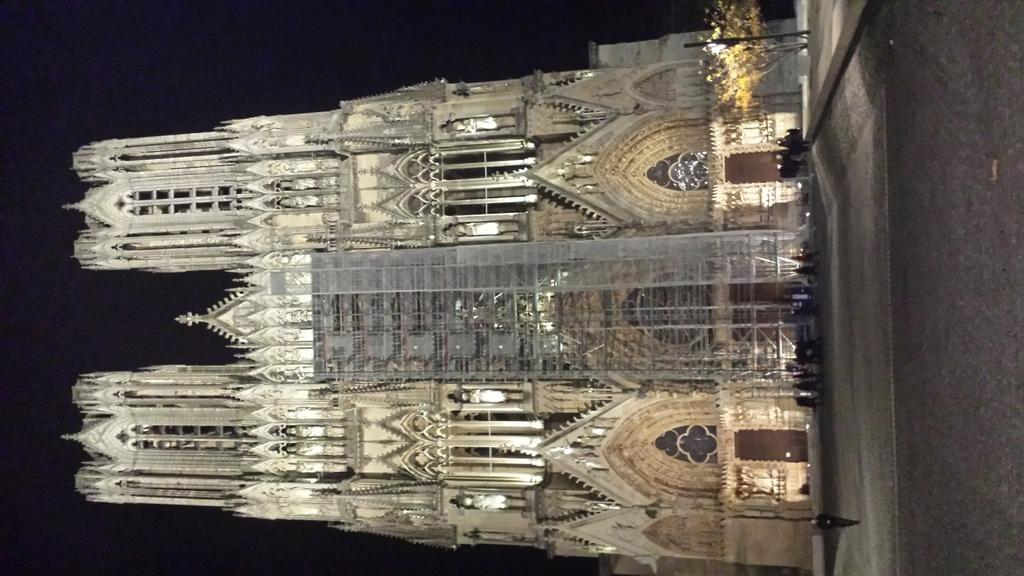What structure is present in the image? There is a building in the image. Can you describe the people in the image? There are persons in the image. What type of vegetation is visible in the image? There are trees in the image. What is the pole in the image used for? The pole in the image is likely used for supporting something, such as a sign or light. What is the source of light in the image? There is light in the image, but the specific source is not mentioned. What is visible in the background of the image? The sky is visible in the background of the image. What direction are the persons in the image having a discussion? There is no indication in the image that the persons are having a discussion. What type of yard is visible in the image? There is no yard present in the image. 